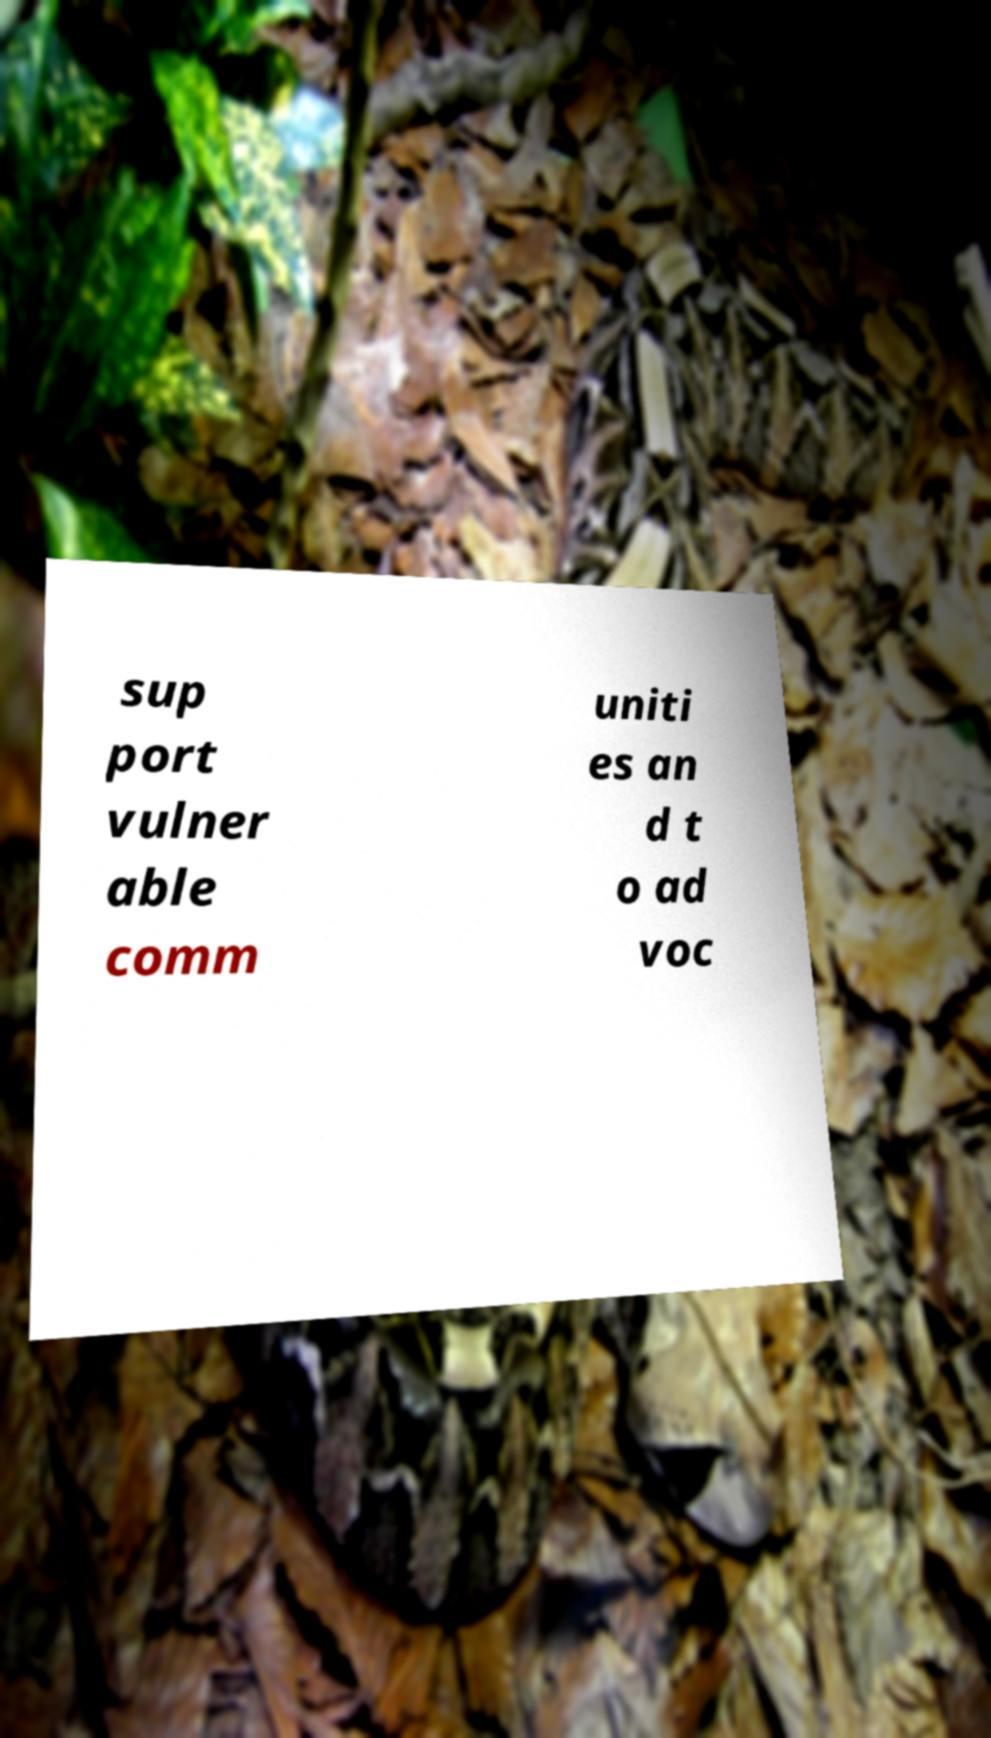Please read and relay the text visible in this image. What does it say? sup port vulner able comm uniti es an d t o ad voc 